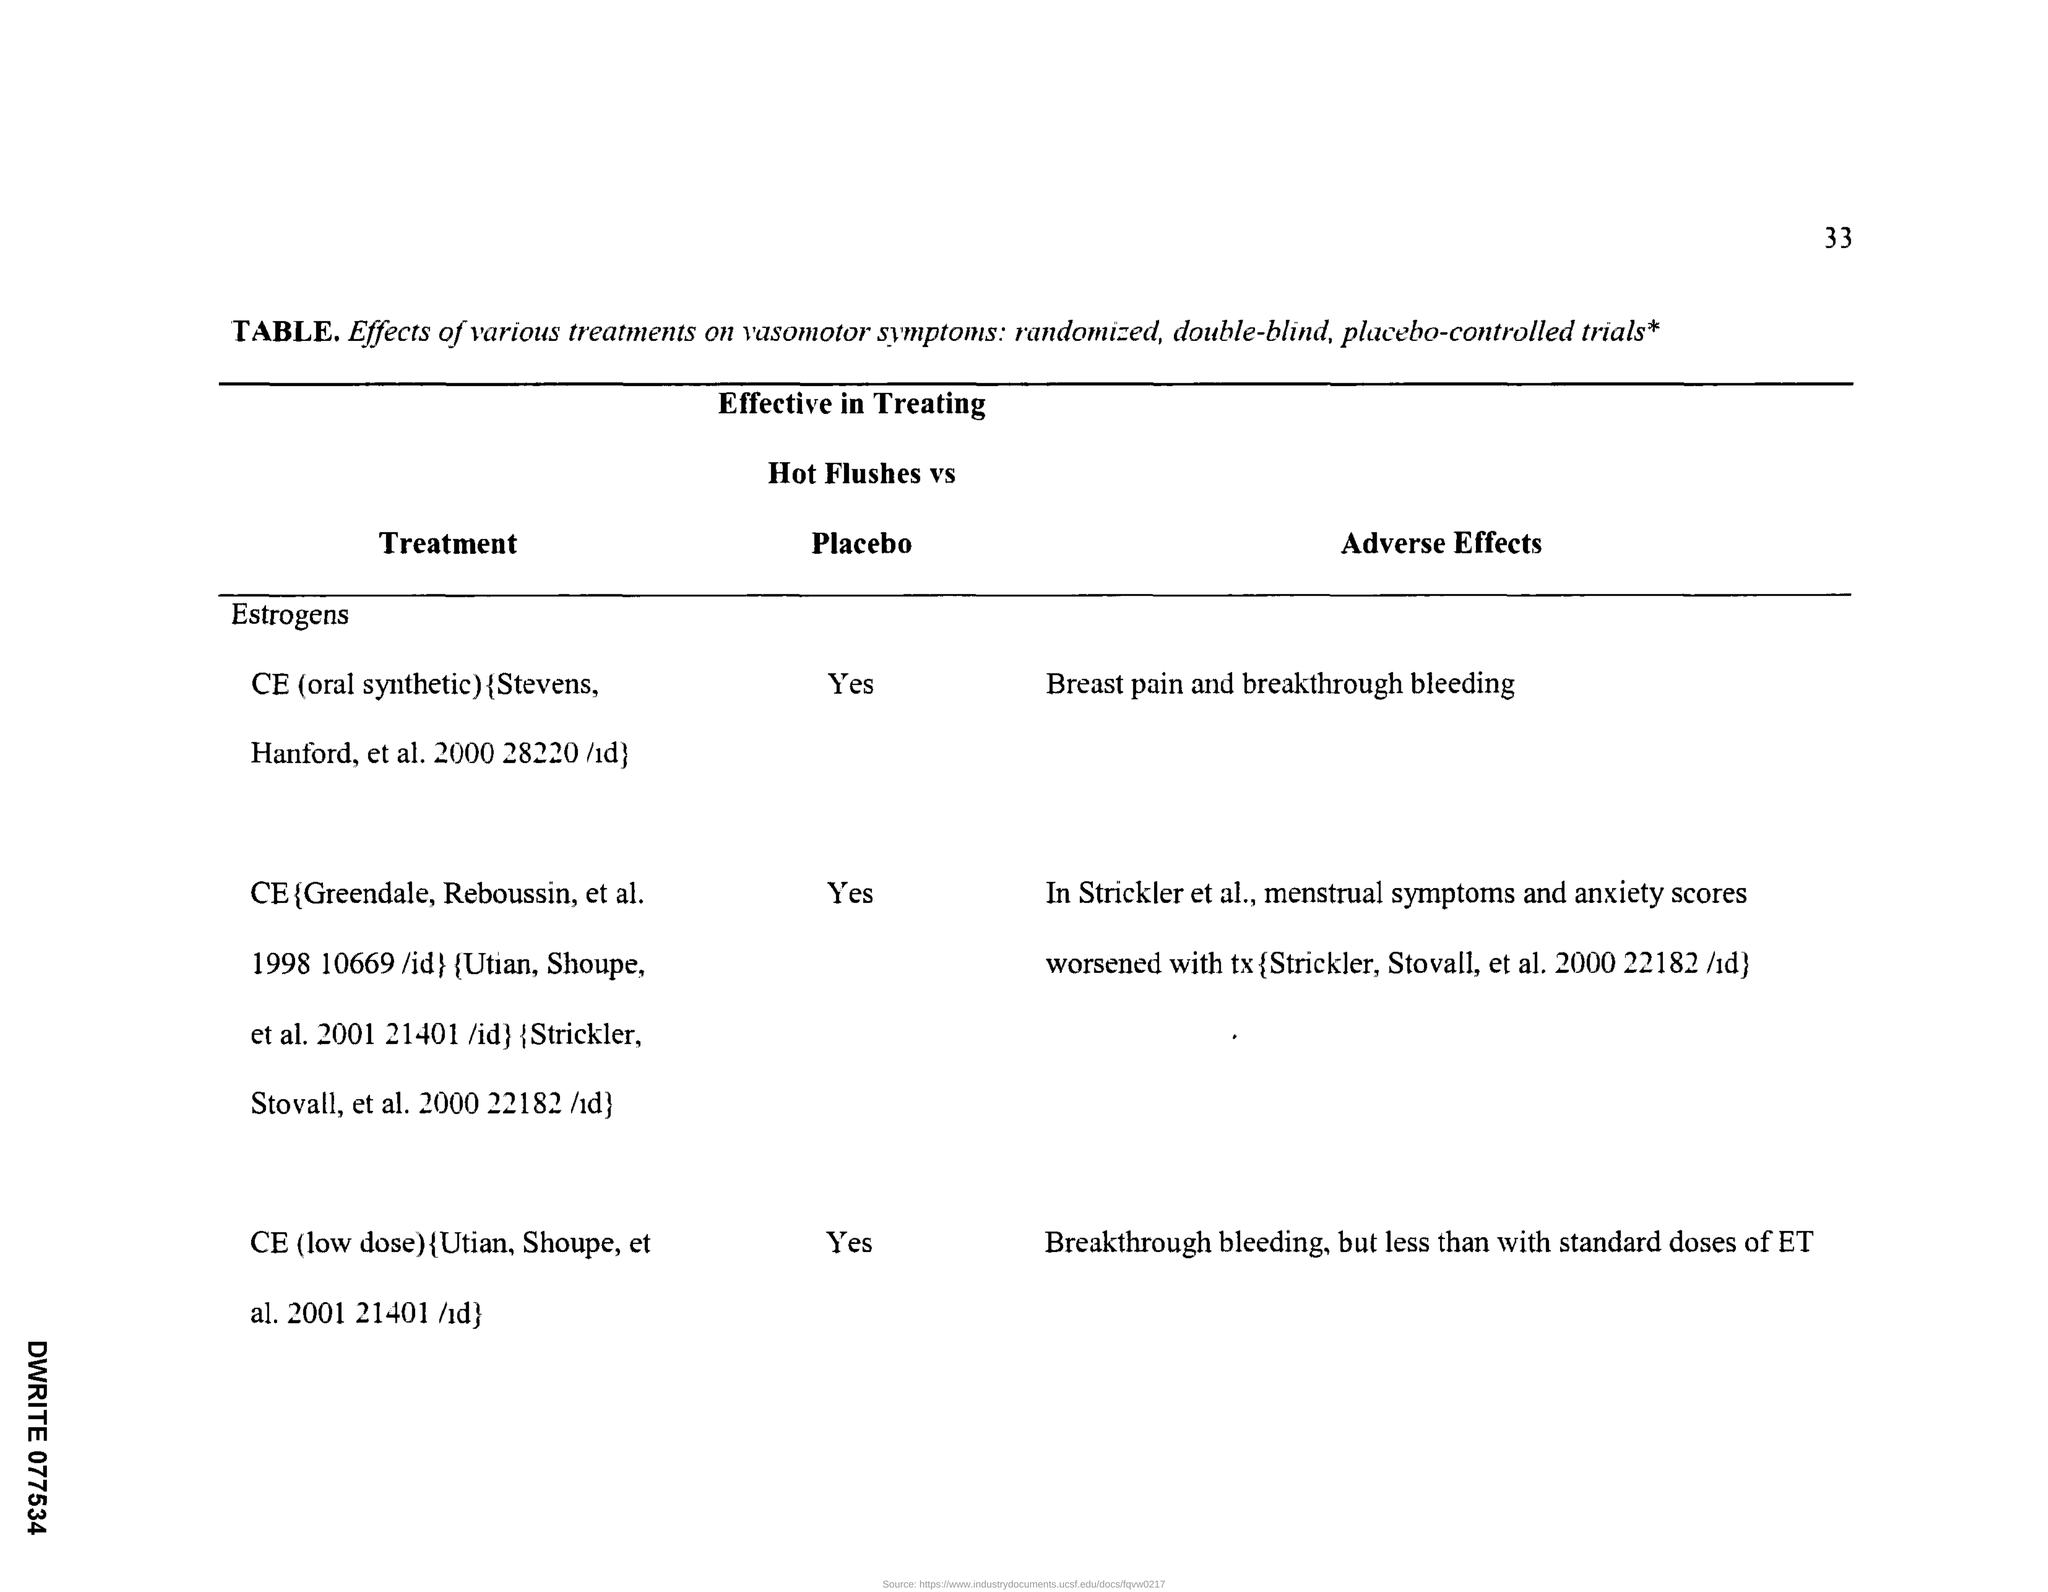What is the Page Number?
Provide a succinct answer. 33. Is CE(low dose) effective in treating hot flushes vs placebo?
Your response must be concise. Yes. Is CE(oral synthetic) effective in treating hot flushes vs placebo?
Provide a short and direct response. Yes. 